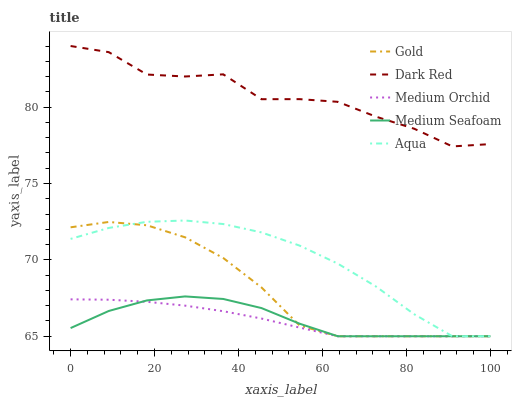Does Medium Orchid have the minimum area under the curve?
Answer yes or no. Yes. Does Dark Red have the maximum area under the curve?
Answer yes or no. Yes. Does Aqua have the minimum area under the curve?
Answer yes or no. No. Does Aqua have the maximum area under the curve?
Answer yes or no. No. Is Medium Orchid the smoothest?
Answer yes or no. Yes. Is Dark Red the roughest?
Answer yes or no. Yes. Is Aqua the smoothest?
Answer yes or no. No. Is Aqua the roughest?
Answer yes or no. No. Does Aqua have the highest value?
Answer yes or no. No. Is Medium Seafoam less than Dark Red?
Answer yes or no. Yes. Is Dark Red greater than Medium Orchid?
Answer yes or no. Yes. Does Medium Seafoam intersect Dark Red?
Answer yes or no. No. 